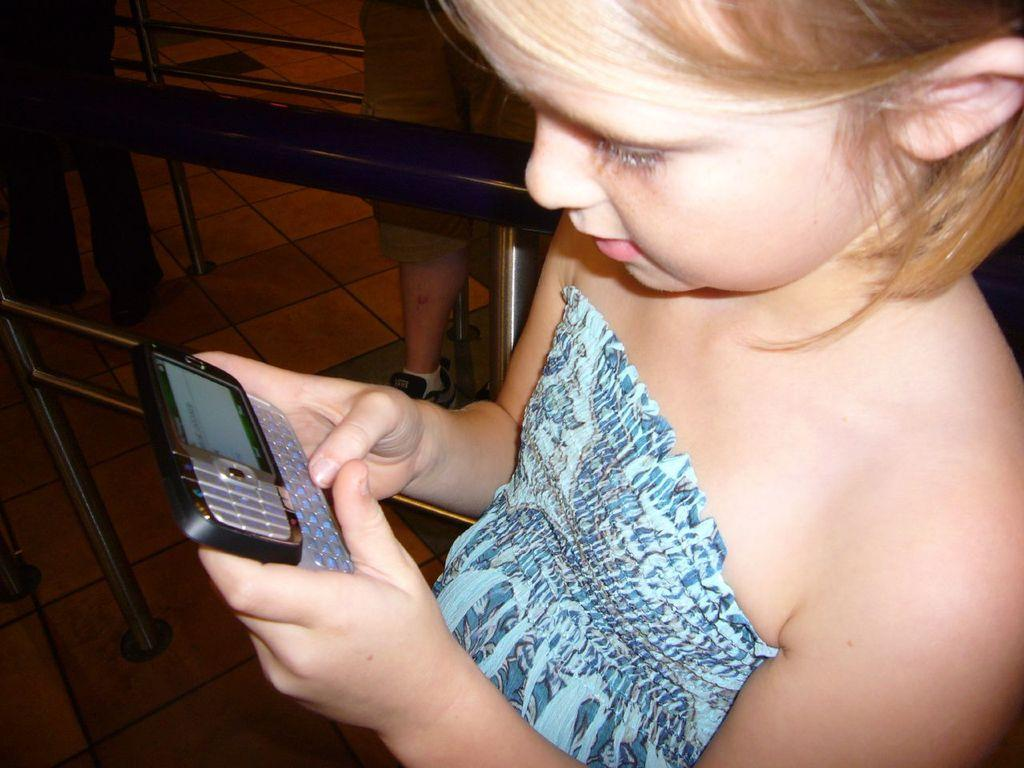Who is the main subject in the image? There is a girl in the image. What is the girl holding in the image? The girl is holding a cellphone. What type of cakes is the girl baking in the image? There is no indication of the girl baking cakes or any other food in the image. 